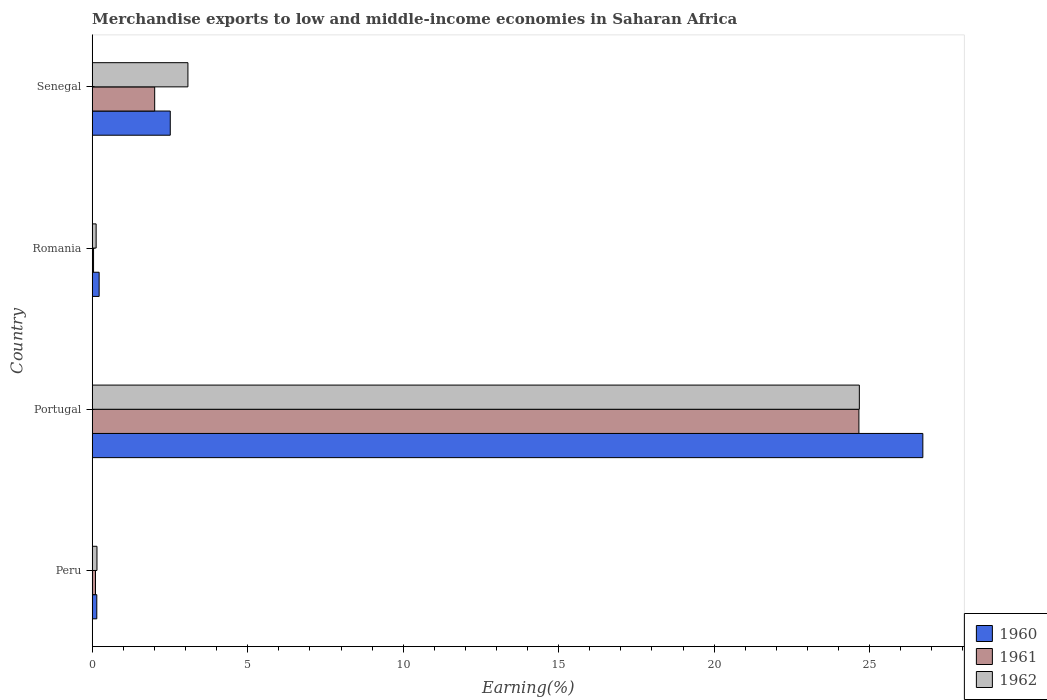How many different coloured bars are there?
Your response must be concise. 3. How many bars are there on the 4th tick from the top?
Keep it short and to the point. 3. How many bars are there on the 4th tick from the bottom?
Give a very brief answer. 3. What is the label of the 4th group of bars from the top?
Ensure brevity in your answer.  Peru. In how many cases, is the number of bars for a given country not equal to the number of legend labels?
Keep it short and to the point. 0. What is the percentage of amount earned from merchandise exports in 1960 in Senegal?
Ensure brevity in your answer.  2.51. Across all countries, what is the maximum percentage of amount earned from merchandise exports in 1961?
Offer a very short reply. 24.65. Across all countries, what is the minimum percentage of amount earned from merchandise exports in 1961?
Provide a short and direct response. 0.04. What is the total percentage of amount earned from merchandise exports in 1961 in the graph?
Offer a very short reply. 26.81. What is the difference between the percentage of amount earned from merchandise exports in 1961 in Romania and that in Senegal?
Give a very brief answer. -1.97. What is the difference between the percentage of amount earned from merchandise exports in 1961 in Peru and the percentage of amount earned from merchandise exports in 1962 in Senegal?
Your answer should be very brief. -2.97. What is the average percentage of amount earned from merchandise exports in 1962 per country?
Keep it short and to the point. 7.01. What is the difference between the percentage of amount earned from merchandise exports in 1961 and percentage of amount earned from merchandise exports in 1960 in Peru?
Offer a terse response. -0.04. In how many countries, is the percentage of amount earned from merchandise exports in 1962 greater than 17 %?
Make the answer very short. 1. What is the ratio of the percentage of amount earned from merchandise exports in 1961 in Peru to that in Portugal?
Give a very brief answer. 0. What is the difference between the highest and the second highest percentage of amount earned from merchandise exports in 1961?
Your answer should be very brief. 22.65. What is the difference between the highest and the lowest percentage of amount earned from merchandise exports in 1962?
Provide a short and direct response. 24.54. Is the sum of the percentage of amount earned from merchandise exports in 1960 in Peru and Senegal greater than the maximum percentage of amount earned from merchandise exports in 1961 across all countries?
Provide a short and direct response. No. What does the 3rd bar from the top in Romania represents?
Your answer should be compact. 1960. Is it the case that in every country, the sum of the percentage of amount earned from merchandise exports in 1961 and percentage of amount earned from merchandise exports in 1962 is greater than the percentage of amount earned from merchandise exports in 1960?
Give a very brief answer. No. How many countries are there in the graph?
Ensure brevity in your answer.  4. Are the values on the major ticks of X-axis written in scientific E-notation?
Make the answer very short. No. Where does the legend appear in the graph?
Keep it short and to the point. Bottom right. How many legend labels are there?
Your response must be concise. 3. What is the title of the graph?
Your answer should be very brief. Merchandise exports to low and middle-income economies in Saharan Africa. Does "1978" appear as one of the legend labels in the graph?
Keep it short and to the point. No. What is the label or title of the X-axis?
Your answer should be compact. Earning(%). What is the Earning(%) of 1960 in Peru?
Provide a succinct answer. 0.15. What is the Earning(%) in 1961 in Peru?
Provide a succinct answer. 0.1. What is the Earning(%) in 1962 in Peru?
Ensure brevity in your answer.  0.15. What is the Earning(%) of 1960 in Portugal?
Offer a very short reply. 26.71. What is the Earning(%) of 1961 in Portugal?
Your answer should be compact. 24.65. What is the Earning(%) in 1962 in Portugal?
Offer a terse response. 24.67. What is the Earning(%) in 1960 in Romania?
Offer a very short reply. 0.22. What is the Earning(%) in 1961 in Romania?
Ensure brevity in your answer.  0.04. What is the Earning(%) in 1962 in Romania?
Provide a succinct answer. 0.13. What is the Earning(%) in 1960 in Senegal?
Offer a very short reply. 2.51. What is the Earning(%) of 1961 in Senegal?
Your response must be concise. 2.01. What is the Earning(%) in 1962 in Senegal?
Provide a short and direct response. 3.08. Across all countries, what is the maximum Earning(%) of 1960?
Give a very brief answer. 26.71. Across all countries, what is the maximum Earning(%) of 1961?
Your answer should be compact. 24.65. Across all countries, what is the maximum Earning(%) in 1962?
Provide a short and direct response. 24.67. Across all countries, what is the minimum Earning(%) in 1960?
Offer a very short reply. 0.15. Across all countries, what is the minimum Earning(%) of 1961?
Your response must be concise. 0.04. Across all countries, what is the minimum Earning(%) in 1962?
Make the answer very short. 0.13. What is the total Earning(%) in 1960 in the graph?
Offer a very short reply. 29.59. What is the total Earning(%) in 1961 in the graph?
Keep it short and to the point. 26.81. What is the total Earning(%) in 1962 in the graph?
Offer a very short reply. 28.02. What is the difference between the Earning(%) in 1960 in Peru and that in Portugal?
Your answer should be compact. -26.56. What is the difference between the Earning(%) of 1961 in Peru and that in Portugal?
Provide a short and direct response. -24.55. What is the difference between the Earning(%) in 1962 in Peru and that in Portugal?
Offer a terse response. -24.52. What is the difference between the Earning(%) in 1960 in Peru and that in Romania?
Offer a very short reply. -0.07. What is the difference between the Earning(%) of 1961 in Peru and that in Romania?
Give a very brief answer. 0.06. What is the difference between the Earning(%) in 1962 in Peru and that in Romania?
Offer a terse response. 0.03. What is the difference between the Earning(%) in 1960 in Peru and that in Senegal?
Your answer should be very brief. -2.36. What is the difference between the Earning(%) in 1961 in Peru and that in Senegal?
Make the answer very short. -1.9. What is the difference between the Earning(%) of 1962 in Peru and that in Senegal?
Your answer should be compact. -2.92. What is the difference between the Earning(%) in 1960 in Portugal and that in Romania?
Your response must be concise. 26.49. What is the difference between the Earning(%) of 1961 in Portugal and that in Romania?
Provide a short and direct response. 24.61. What is the difference between the Earning(%) of 1962 in Portugal and that in Romania?
Make the answer very short. 24.54. What is the difference between the Earning(%) of 1960 in Portugal and that in Senegal?
Your response must be concise. 24.2. What is the difference between the Earning(%) in 1961 in Portugal and that in Senegal?
Provide a short and direct response. 22.65. What is the difference between the Earning(%) of 1962 in Portugal and that in Senegal?
Provide a succinct answer. 21.59. What is the difference between the Earning(%) of 1960 in Romania and that in Senegal?
Provide a short and direct response. -2.29. What is the difference between the Earning(%) of 1961 in Romania and that in Senegal?
Provide a short and direct response. -1.97. What is the difference between the Earning(%) of 1962 in Romania and that in Senegal?
Offer a terse response. -2.95. What is the difference between the Earning(%) in 1960 in Peru and the Earning(%) in 1961 in Portugal?
Make the answer very short. -24.51. What is the difference between the Earning(%) in 1960 in Peru and the Earning(%) in 1962 in Portugal?
Keep it short and to the point. -24.52. What is the difference between the Earning(%) in 1961 in Peru and the Earning(%) in 1962 in Portugal?
Ensure brevity in your answer.  -24.56. What is the difference between the Earning(%) of 1960 in Peru and the Earning(%) of 1961 in Romania?
Provide a succinct answer. 0.1. What is the difference between the Earning(%) in 1960 in Peru and the Earning(%) in 1962 in Romania?
Your answer should be compact. 0.02. What is the difference between the Earning(%) in 1961 in Peru and the Earning(%) in 1962 in Romania?
Provide a succinct answer. -0.02. What is the difference between the Earning(%) in 1960 in Peru and the Earning(%) in 1961 in Senegal?
Your answer should be compact. -1.86. What is the difference between the Earning(%) of 1960 in Peru and the Earning(%) of 1962 in Senegal?
Give a very brief answer. -2.93. What is the difference between the Earning(%) in 1961 in Peru and the Earning(%) in 1962 in Senegal?
Your answer should be compact. -2.97. What is the difference between the Earning(%) in 1960 in Portugal and the Earning(%) in 1961 in Romania?
Your answer should be compact. 26.67. What is the difference between the Earning(%) in 1960 in Portugal and the Earning(%) in 1962 in Romania?
Provide a short and direct response. 26.58. What is the difference between the Earning(%) in 1961 in Portugal and the Earning(%) in 1962 in Romania?
Offer a very short reply. 24.53. What is the difference between the Earning(%) in 1960 in Portugal and the Earning(%) in 1961 in Senegal?
Provide a succinct answer. 24.7. What is the difference between the Earning(%) in 1960 in Portugal and the Earning(%) in 1962 in Senegal?
Provide a short and direct response. 23.63. What is the difference between the Earning(%) of 1961 in Portugal and the Earning(%) of 1962 in Senegal?
Make the answer very short. 21.58. What is the difference between the Earning(%) of 1960 in Romania and the Earning(%) of 1961 in Senegal?
Provide a succinct answer. -1.79. What is the difference between the Earning(%) in 1960 in Romania and the Earning(%) in 1962 in Senegal?
Make the answer very short. -2.86. What is the difference between the Earning(%) in 1961 in Romania and the Earning(%) in 1962 in Senegal?
Ensure brevity in your answer.  -3.04. What is the average Earning(%) in 1960 per country?
Give a very brief answer. 7.4. What is the average Earning(%) in 1961 per country?
Make the answer very short. 6.7. What is the average Earning(%) of 1962 per country?
Make the answer very short. 7.01. What is the difference between the Earning(%) of 1960 and Earning(%) of 1961 in Peru?
Your response must be concise. 0.04. What is the difference between the Earning(%) in 1960 and Earning(%) in 1962 in Peru?
Provide a short and direct response. -0.01. What is the difference between the Earning(%) of 1961 and Earning(%) of 1962 in Peru?
Ensure brevity in your answer.  -0.05. What is the difference between the Earning(%) of 1960 and Earning(%) of 1961 in Portugal?
Make the answer very short. 2.06. What is the difference between the Earning(%) in 1960 and Earning(%) in 1962 in Portugal?
Your response must be concise. 2.04. What is the difference between the Earning(%) of 1961 and Earning(%) of 1962 in Portugal?
Give a very brief answer. -0.01. What is the difference between the Earning(%) of 1960 and Earning(%) of 1961 in Romania?
Keep it short and to the point. 0.18. What is the difference between the Earning(%) in 1960 and Earning(%) in 1962 in Romania?
Provide a short and direct response. 0.1. What is the difference between the Earning(%) in 1961 and Earning(%) in 1962 in Romania?
Offer a terse response. -0.08. What is the difference between the Earning(%) in 1960 and Earning(%) in 1961 in Senegal?
Offer a very short reply. 0.5. What is the difference between the Earning(%) in 1960 and Earning(%) in 1962 in Senegal?
Offer a very short reply. -0.57. What is the difference between the Earning(%) in 1961 and Earning(%) in 1962 in Senegal?
Ensure brevity in your answer.  -1.07. What is the ratio of the Earning(%) in 1960 in Peru to that in Portugal?
Offer a very short reply. 0.01. What is the ratio of the Earning(%) of 1961 in Peru to that in Portugal?
Your response must be concise. 0. What is the ratio of the Earning(%) of 1962 in Peru to that in Portugal?
Your answer should be compact. 0.01. What is the ratio of the Earning(%) of 1960 in Peru to that in Romania?
Offer a terse response. 0.66. What is the ratio of the Earning(%) in 1961 in Peru to that in Romania?
Your answer should be very brief. 2.51. What is the ratio of the Earning(%) in 1962 in Peru to that in Romania?
Keep it short and to the point. 1.21. What is the ratio of the Earning(%) of 1960 in Peru to that in Senegal?
Your answer should be very brief. 0.06. What is the ratio of the Earning(%) in 1961 in Peru to that in Senegal?
Your response must be concise. 0.05. What is the ratio of the Earning(%) in 1962 in Peru to that in Senegal?
Ensure brevity in your answer.  0.05. What is the ratio of the Earning(%) of 1960 in Portugal to that in Romania?
Your answer should be compact. 120.48. What is the ratio of the Earning(%) in 1961 in Portugal to that in Romania?
Keep it short and to the point. 588.91. What is the ratio of the Earning(%) of 1962 in Portugal to that in Romania?
Give a very brief answer. 196.67. What is the ratio of the Earning(%) in 1960 in Portugal to that in Senegal?
Your answer should be very brief. 10.65. What is the ratio of the Earning(%) in 1961 in Portugal to that in Senegal?
Give a very brief answer. 12.28. What is the ratio of the Earning(%) of 1962 in Portugal to that in Senegal?
Keep it short and to the point. 8.02. What is the ratio of the Earning(%) in 1960 in Romania to that in Senegal?
Provide a succinct answer. 0.09. What is the ratio of the Earning(%) of 1961 in Romania to that in Senegal?
Ensure brevity in your answer.  0.02. What is the ratio of the Earning(%) in 1962 in Romania to that in Senegal?
Offer a terse response. 0.04. What is the difference between the highest and the second highest Earning(%) of 1960?
Give a very brief answer. 24.2. What is the difference between the highest and the second highest Earning(%) in 1961?
Make the answer very short. 22.65. What is the difference between the highest and the second highest Earning(%) in 1962?
Provide a succinct answer. 21.59. What is the difference between the highest and the lowest Earning(%) of 1960?
Provide a short and direct response. 26.56. What is the difference between the highest and the lowest Earning(%) in 1961?
Your answer should be compact. 24.61. What is the difference between the highest and the lowest Earning(%) of 1962?
Offer a very short reply. 24.54. 